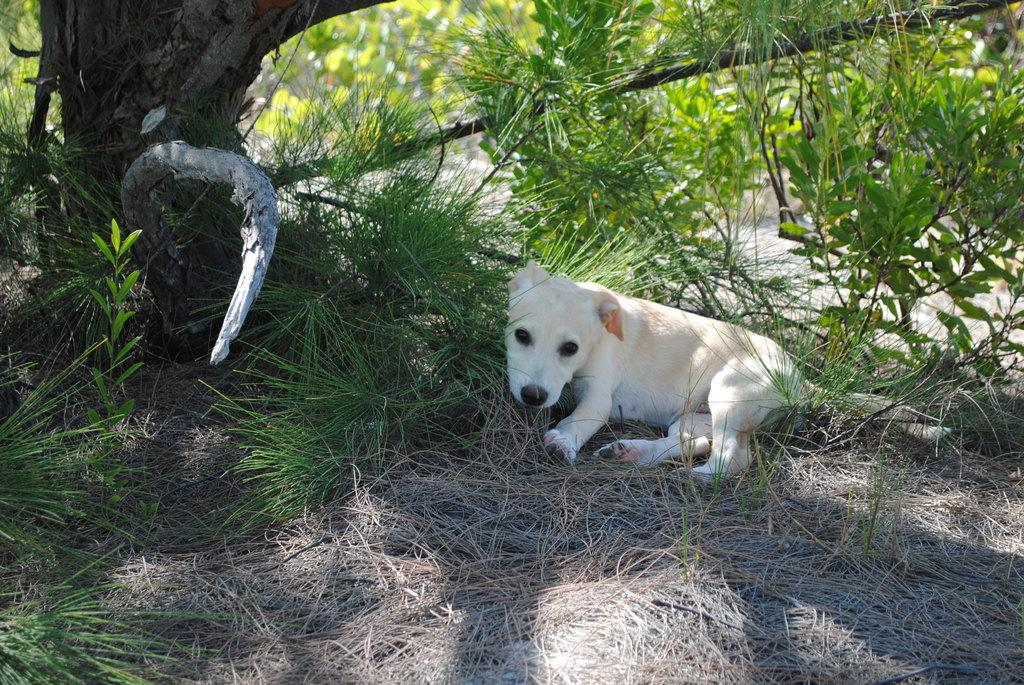What type of animal can be seen in the image? There is a dog in the image. What is the dog doing in the image? The dog is lying on the grass. What can be seen in the background of the image? There are trees in the background of the image. How many boys are flying the plane in the image? There is no plane or boys present in the image; it features a dog lying on the grass with trees in the background. 